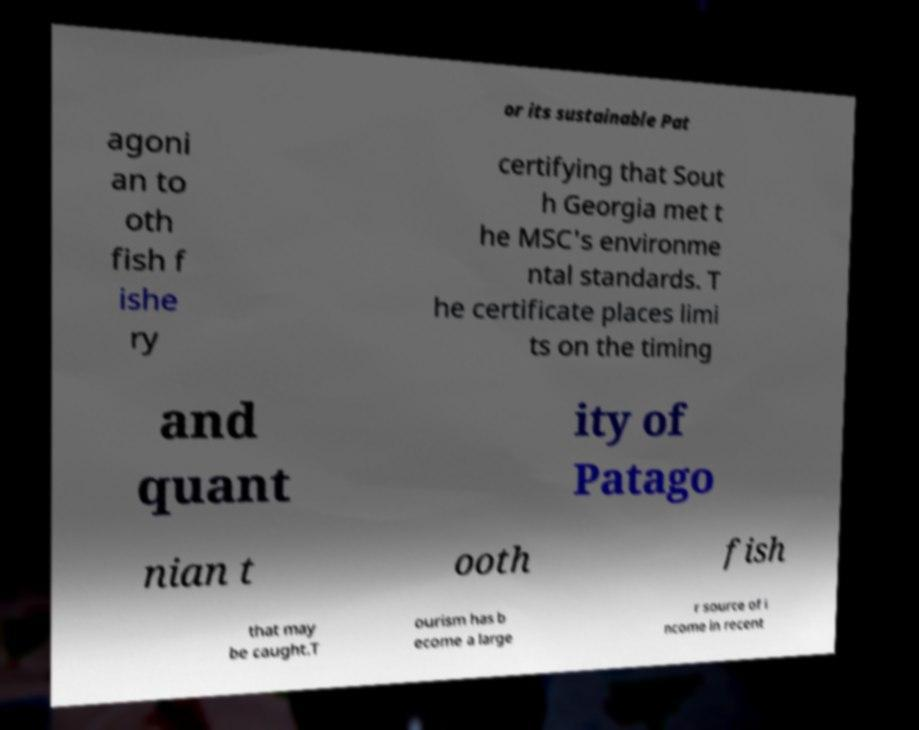For documentation purposes, I need the text within this image transcribed. Could you provide that? or its sustainable Pat agoni an to oth fish f ishe ry certifying that Sout h Georgia met t he MSC's environme ntal standards. T he certificate places limi ts on the timing and quant ity of Patago nian t ooth fish that may be caught.T ourism has b ecome a large r source of i ncome in recent 